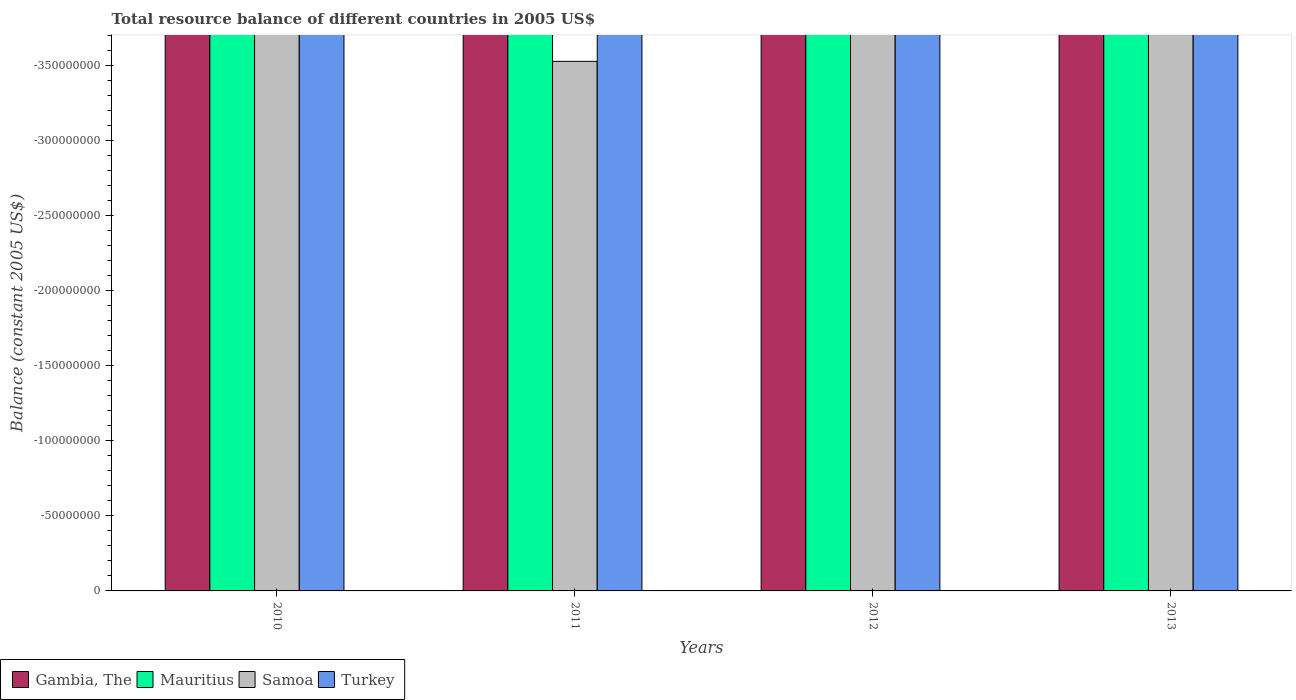How many bars are there on the 1st tick from the left?
Give a very brief answer. 0. What is the label of the 2nd group of bars from the left?
Your answer should be compact. 2011. Across all years, what is the minimum total resource balance in Turkey?
Provide a short and direct response. 0. What is the total total resource balance in Samoa in the graph?
Provide a succinct answer. 0. What is the average total resource balance in Turkey per year?
Offer a very short reply. 0. In how many years, is the total resource balance in Samoa greater than -170000000 US$?
Your answer should be compact. 0. In how many years, is the total resource balance in Mauritius greater than the average total resource balance in Mauritius taken over all years?
Your response must be concise. 0. Is it the case that in every year, the sum of the total resource balance in Mauritius and total resource balance in Samoa is greater than the total resource balance in Gambia, The?
Make the answer very short. No. How many bars are there?
Your answer should be compact. 0. What is the difference between two consecutive major ticks on the Y-axis?
Provide a succinct answer. 5.00e+07. Are the values on the major ticks of Y-axis written in scientific E-notation?
Offer a very short reply. No. Does the graph contain grids?
Your response must be concise. No. How are the legend labels stacked?
Your answer should be very brief. Horizontal. What is the title of the graph?
Provide a succinct answer. Total resource balance of different countries in 2005 US$. What is the label or title of the X-axis?
Give a very brief answer. Years. What is the label or title of the Y-axis?
Offer a very short reply. Balance (constant 2005 US$). What is the Balance (constant 2005 US$) in Gambia, The in 2010?
Your answer should be compact. 0. What is the Balance (constant 2005 US$) of Gambia, The in 2011?
Ensure brevity in your answer.  0. What is the Balance (constant 2005 US$) of Gambia, The in 2012?
Your answer should be compact. 0. What is the Balance (constant 2005 US$) of Mauritius in 2012?
Provide a short and direct response. 0. What is the Balance (constant 2005 US$) in Turkey in 2012?
Keep it short and to the point. 0. What is the Balance (constant 2005 US$) in Mauritius in 2013?
Provide a short and direct response. 0. What is the Balance (constant 2005 US$) in Turkey in 2013?
Provide a short and direct response. 0. What is the total Balance (constant 2005 US$) in Turkey in the graph?
Your response must be concise. 0. What is the average Balance (constant 2005 US$) of Mauritius per year?
Your response must be concise. 0. 